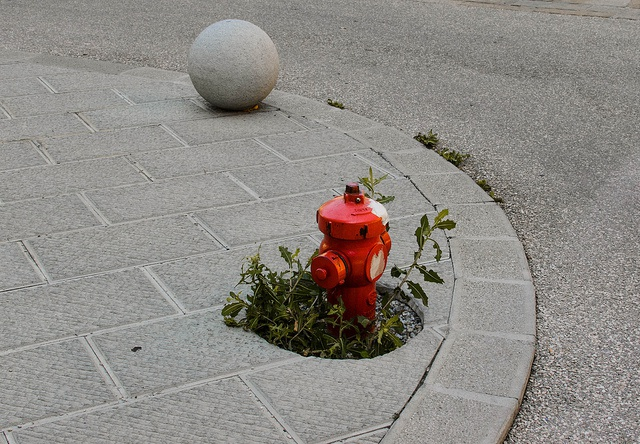Describe the objects in this image and their specific colors. I can see a fire hydrant in gray, maroon, black, and salmon tones in this image. 